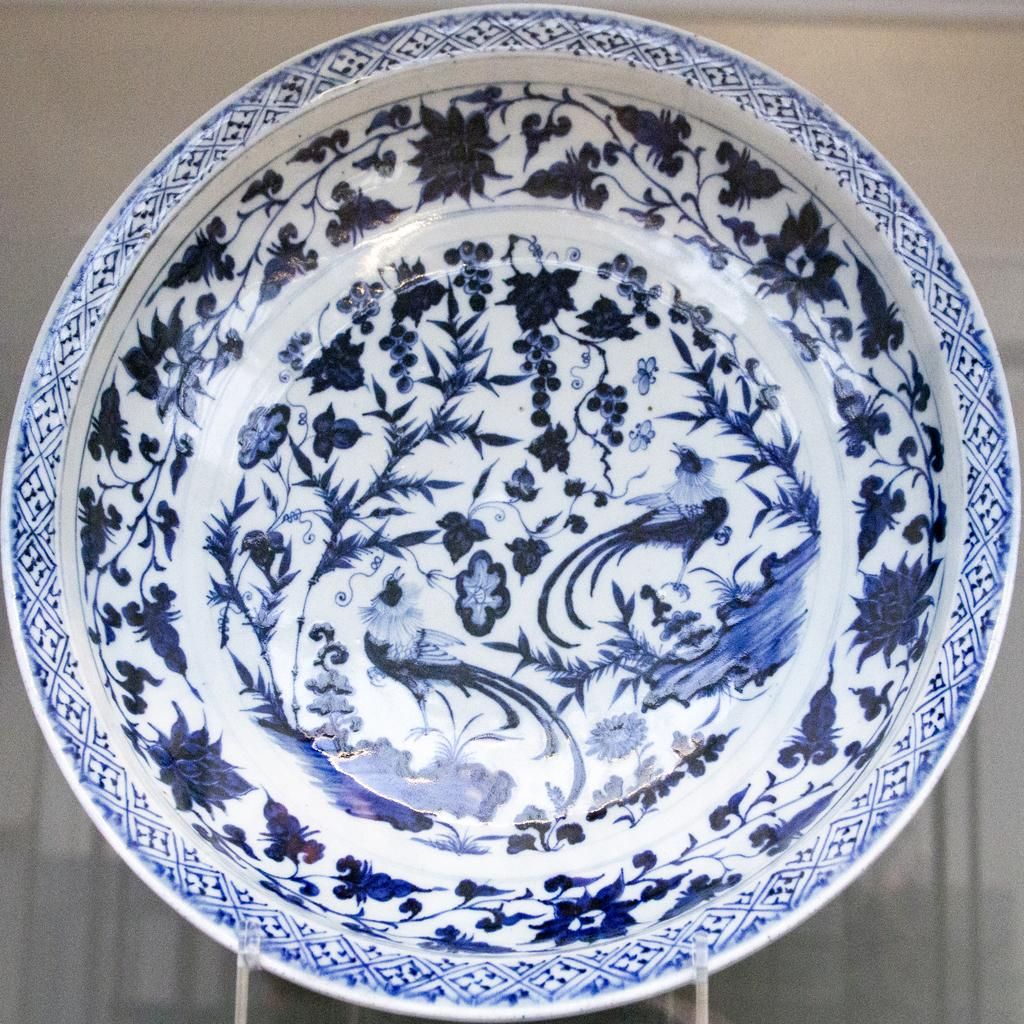What object is present on a table in the image? There is a plate in the image. What is the design on the plate? The plate has floral designs. What type of coach is visible in the image? There is no coach present in the image; it only features a plate with floral designs on a table. 